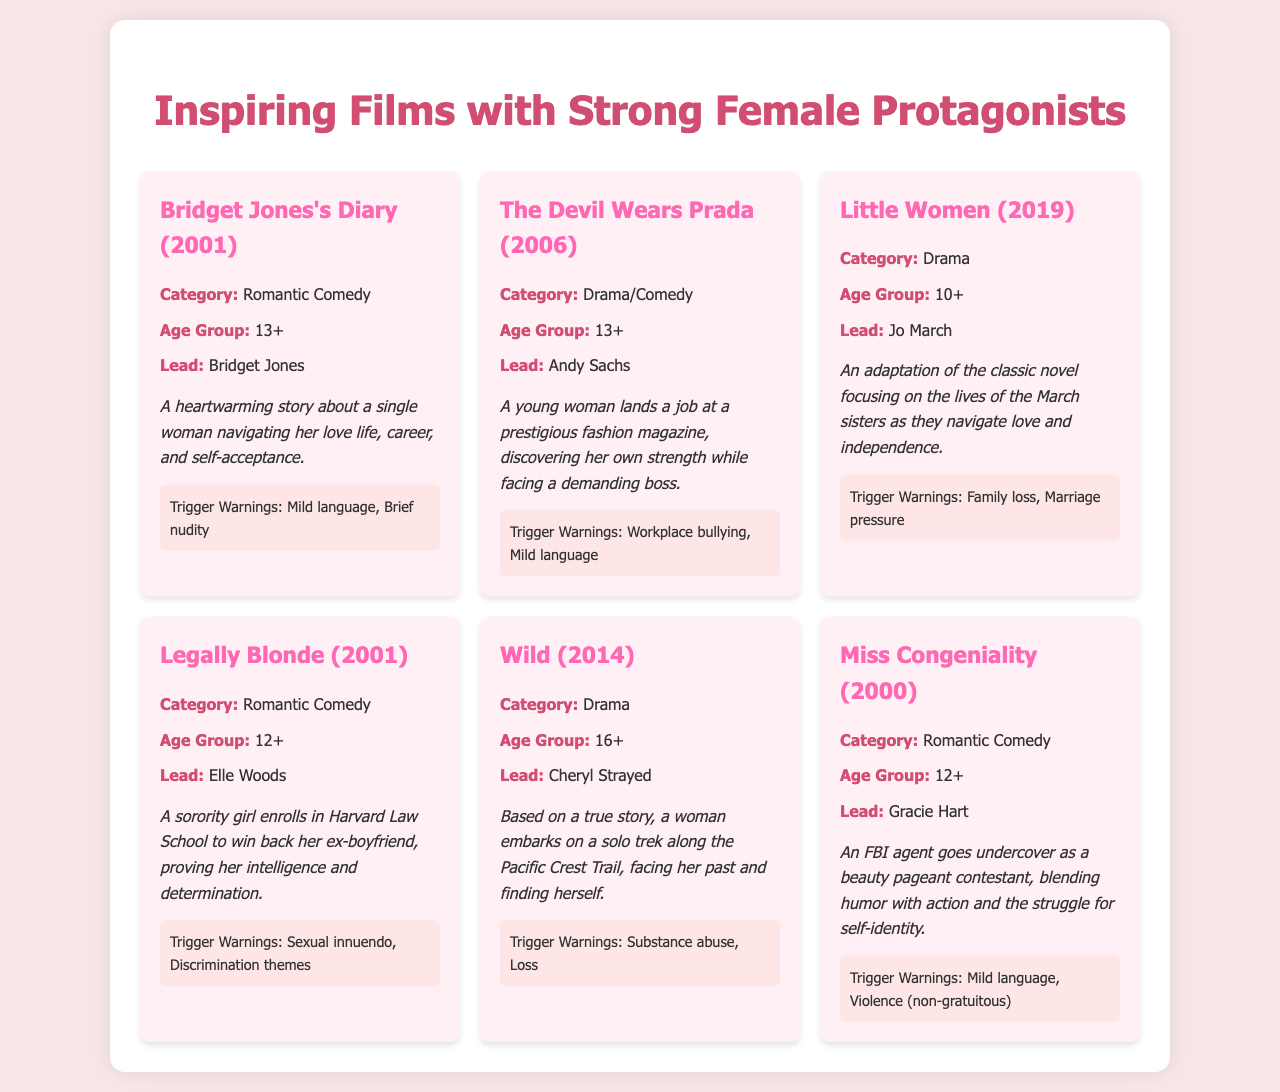What is the title of the first film listed? The first film listed in the document is "Bridget Jones's Diary (2001)."
Answer: Bridget Jones's Diary (2001) What is the lead character of "Little Women"? The lead character of "Little Women" is Jo March.
Answer: Jo March What category does "Wild" belong to? The film "Wild" is categorized as Drama.
Answer: Drama How many films are categorized as Romantic Comedy? There are three films categorized as Romantic Comedy.
Answer: three What are the trigger warnings for "The Devil Wears Prada"? The trigger warnings for "The Devil Wears Prada" include workplace bullying and mild language.
Answer: Workplace bullying, Mild language Which film has an age group rating of 10+? The film with an age group rating of 10+ is "Little Women."
Answer: Little Women What is the lead character of "Legally Blonde"? The lead character of "Legally Blonde" is Elle Woods.
Answer: Elle Woods What year was "Miss Congeniality" released? "Miss Congeniality" was released in the year 2000.
Answer: 2000 What is the main theme of "Bridget Jones's Diary"? The main theme of "Bridget Jones's Diary" centers around a single woman navigating her love life, career, and self-acceptance.
Answer: Navigating love life, career, self-acceptance 